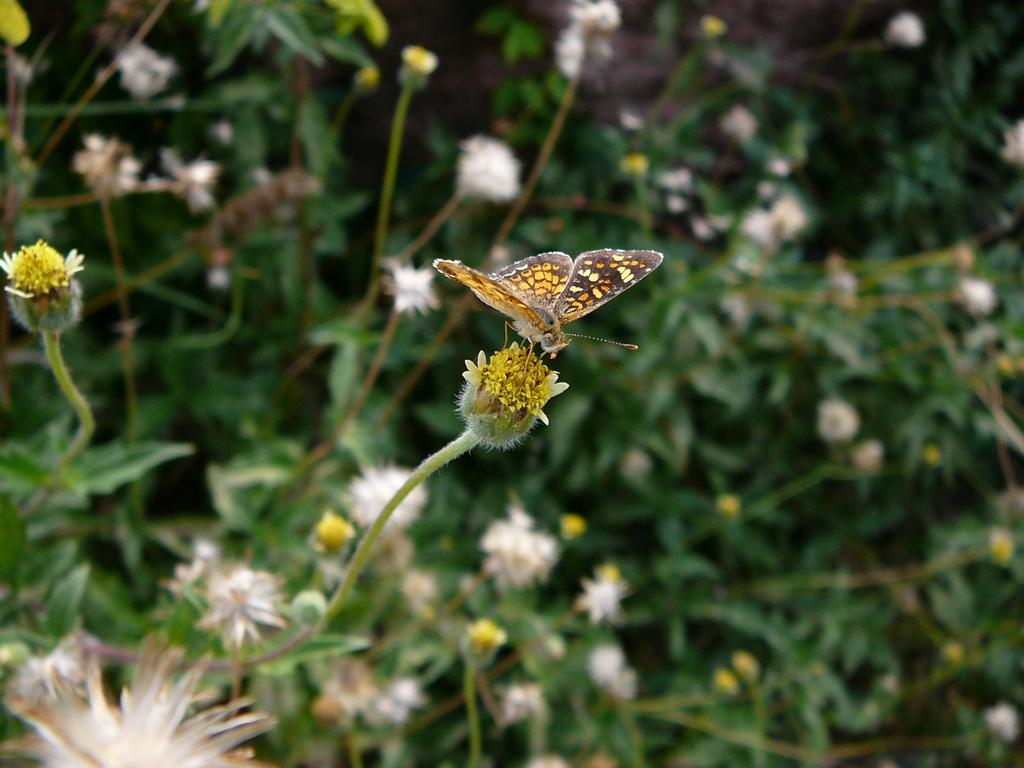What is the main subject of the image? There is a butterfly in the image. Where is the butterfly located in the image? The butterfly is sitting on a flower. What can be seen in the background of the image? There are flowers and leaves in the background of the image. How many holes can be seen in the image? There are no holes present in the image. What type of tin is visible in the image? There is no tin present in the image. 